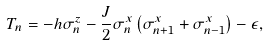Convert formula to latex. <formula><loc_0><loc_0><loc_500><loc_500>T _ { n } = - h \sigma _ { n } ^ { z } - \frac { J } { 2 } \sigma _ { n } ^ { x } \left ( \sigma _ { n + 1 } ^ { x } + \sigma _ { n - 1 } ^ { x } \right ) - \epsilon ,</formula> 